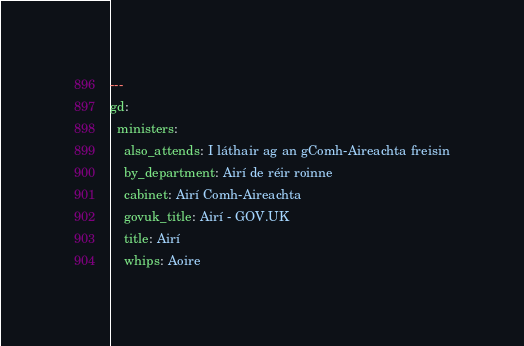<code> <loc_0><loc_0><loc_500><loc_500><_YAML_>---
gd:
  ministers:
    also_attends: I láthair ag an gComh-Aireachta freisin
    by_department: Airí de réir roinne
    cabinet: Airí Comh-Aireachta
    govuk_title: Airí - GOV.UK
    title: Airí
    whips: Aoire
</code> 